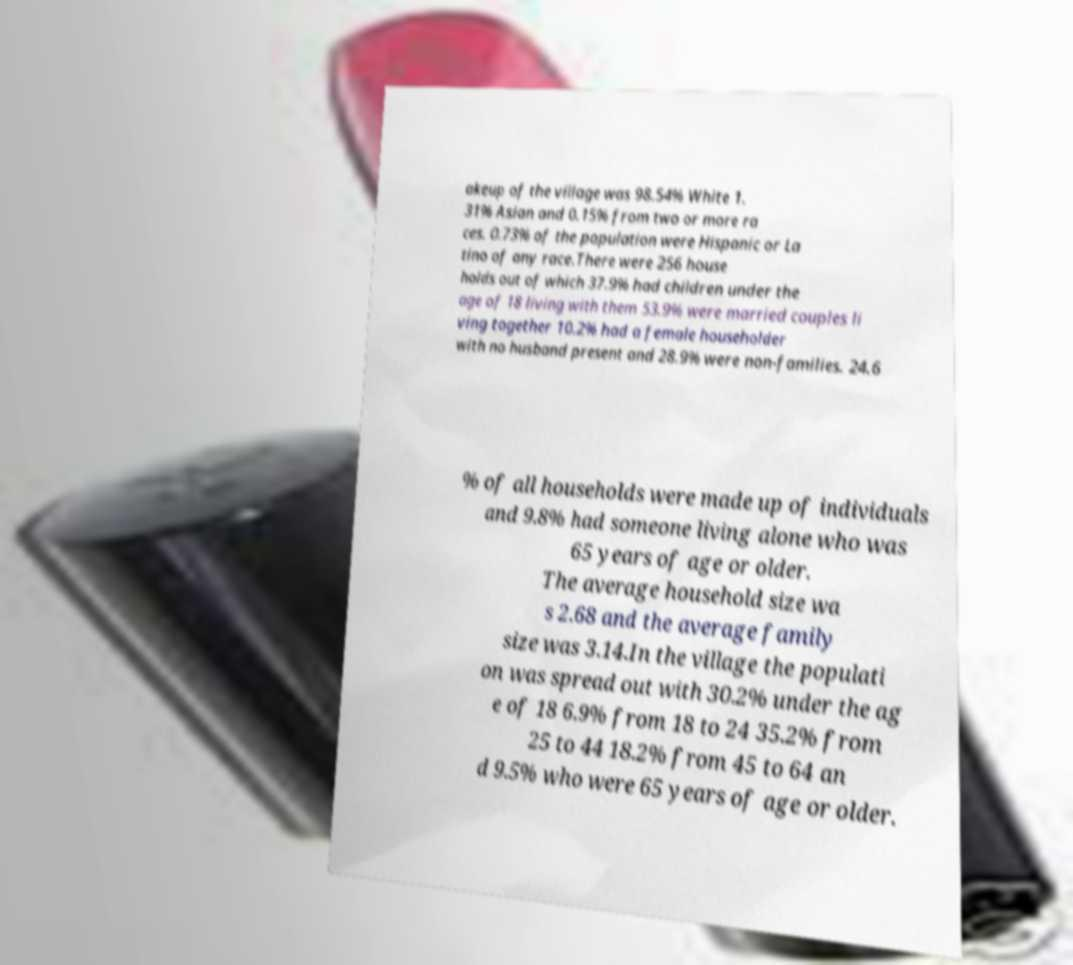Could you assist in decoding the text presented in this image and type it out clearly? akeup of the village was 98.54% White 1. 31% Asian and 0.15% from two or more ra ces. 0.73% of the population were Hispanic or La tino of any race.There were 256 house holds out of which 37.9% had children under the age of 18 living with them 53.9% were married couples li ving together 10.2% had a female householder with no husband present and 28.9% were non-families. 24.6 % of all households were made up of individuals and 9.8% had someone living alone who was 65 years of age or older. The average household size wa s 2.68 and the average family size was 3.14.In the village the populati on was spread out with 30.2% under the ag e of 18 6.9% from 18 to 24 35.2% from 25 to 44 18.2% from 45 to 64 an d 9.5% who were 65 years of age or older. 